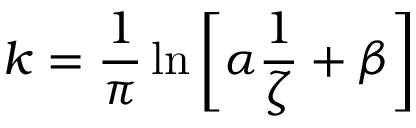<formula> <loc_0><loc_0><loc_500><loc_500>k = \frac { 1 } { \pi } \ln { \left [ \alpha \frac { 1 } { \zeta } + \beta \right ] }</formula> 